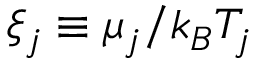Convert formula to latex. <formula><loc_0><loc_0><loc_500><loc_500>\xi _ { j } \equiv \mu _ { j } / k _ { B } T _ { j }</formula> 